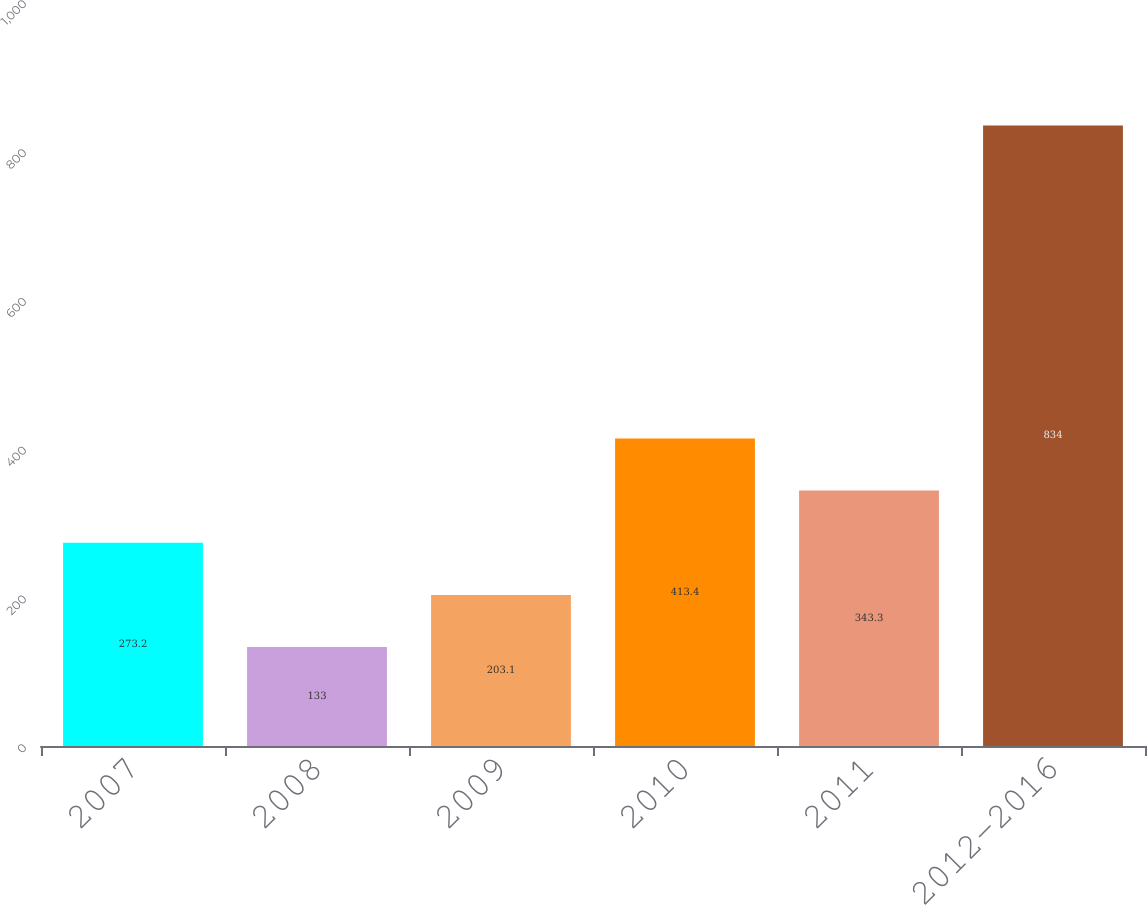Convert chart. <chart><loc_0><loc_0><loc_500><loc_500><bar_chart><fcel>2007<fcel>2008<fcel>2009<fcel>2010<fcel>2011<fcel>2012-2016<nl><fcel>273.2<fcel>133<fcel>203.1<fcel>413.4<fcel>343.3<fcel>834<nl></chart> 